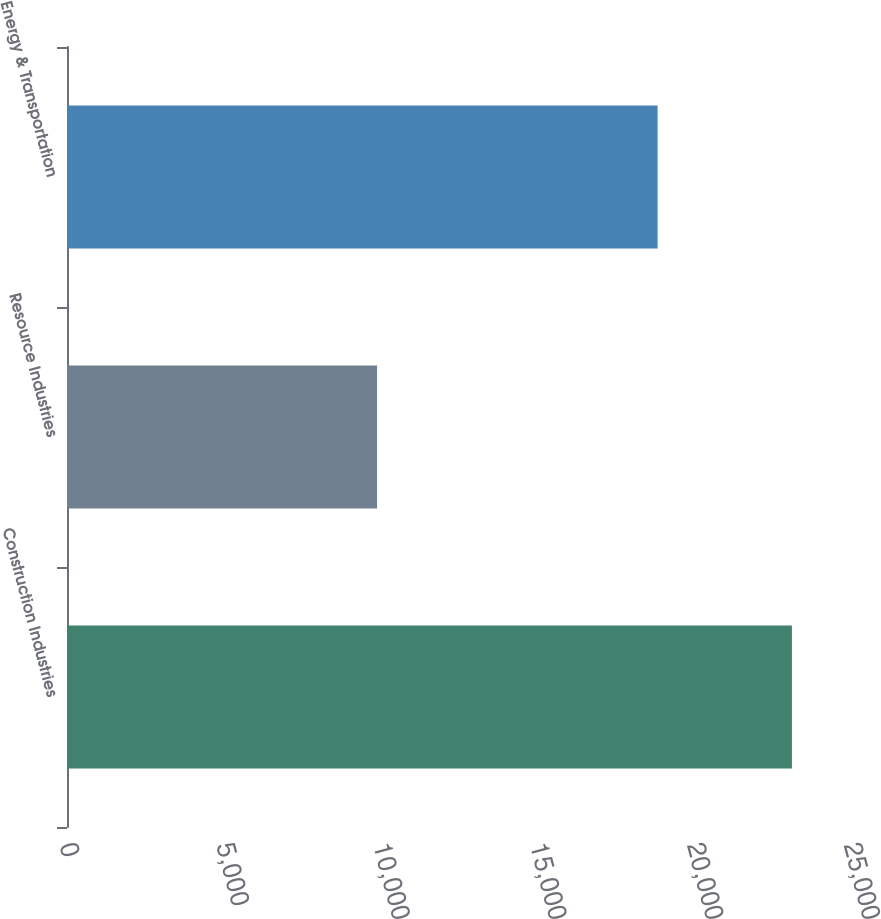<chart> <loc_0><loc_0><loc_500><loc_500><bar_chart><fcel>Construction Industries<fcel>Resource Industries<fcel>Energy & Transportation<nl><fcel>23116<fcel>9888<fcel>18832<nl></chart> 